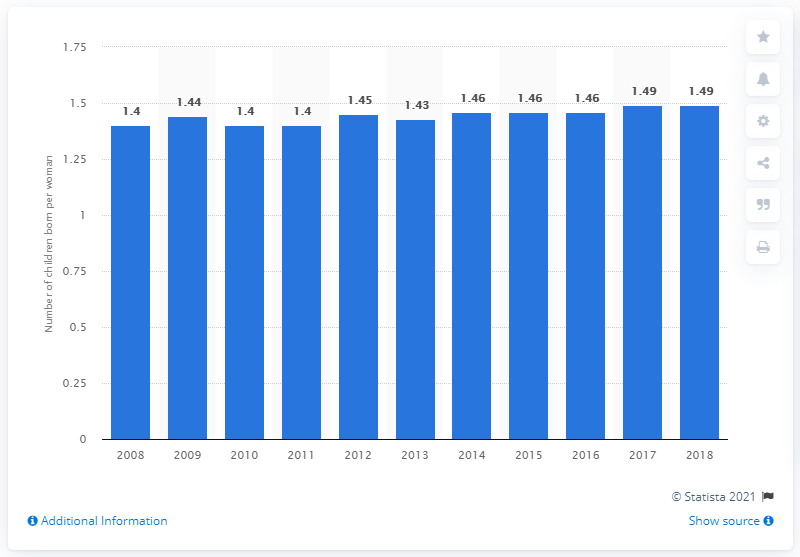Outline some significant characteristics in this image. The fertility rate in Serbia in 2018 was 1.49, which is below the replacement rate of 2.1. 